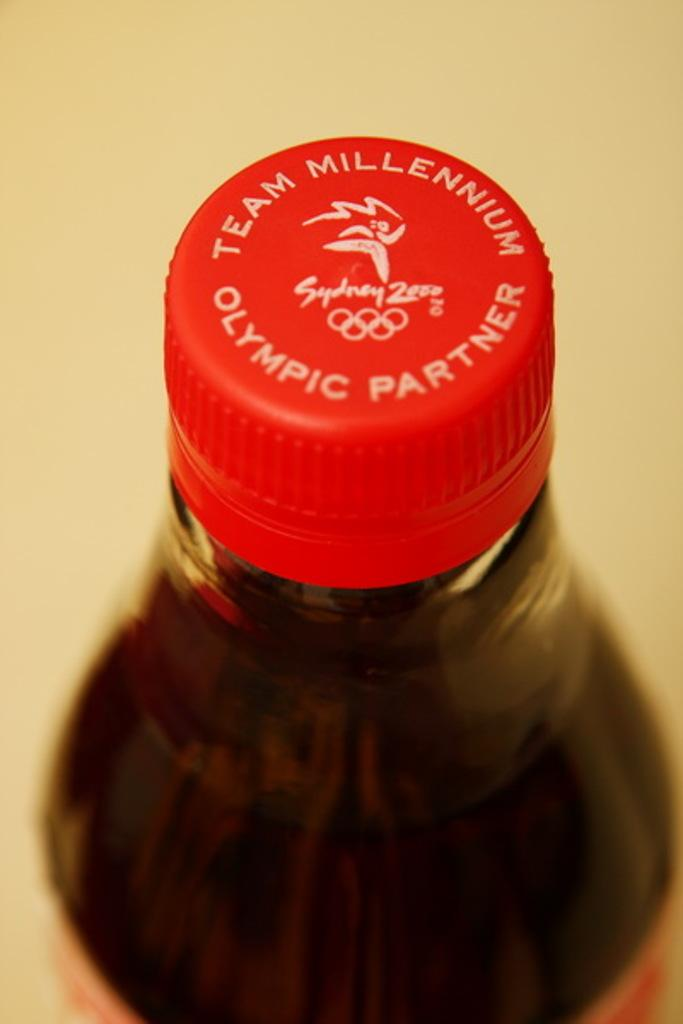<image>
Give a short and clear explanation of the subsequent image. A bottle cap of a drinks brand that is an Olympics partner. 